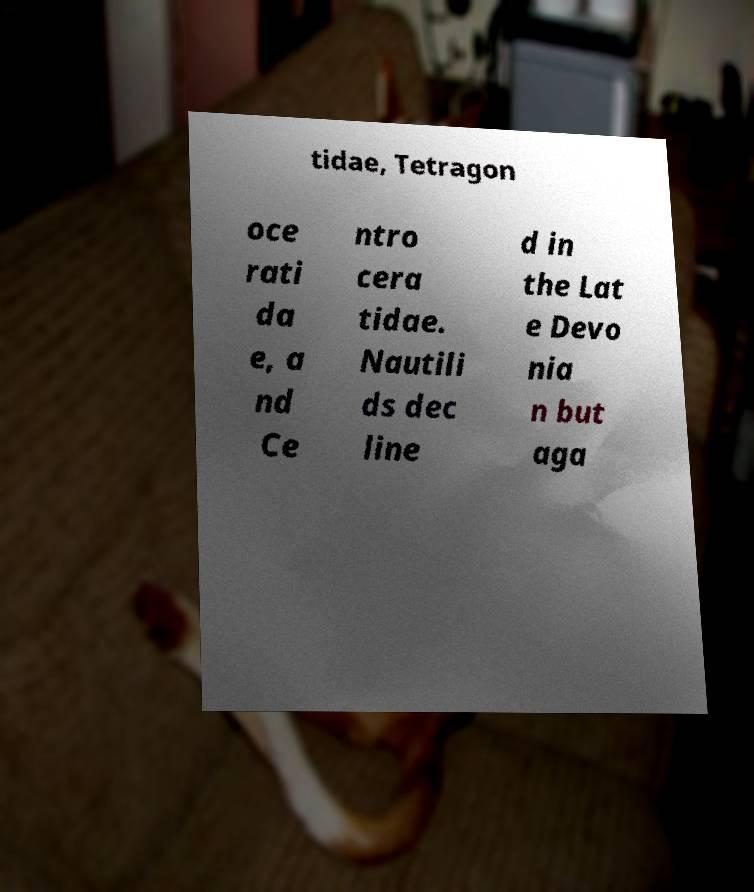Can you accurately transcribe the text from the provided image for me? tidae, Tetragon oce rati da e, a nd Ce ntro cera tidae. Nautili ds dec line d in the Lat e Devo nia n but aga 